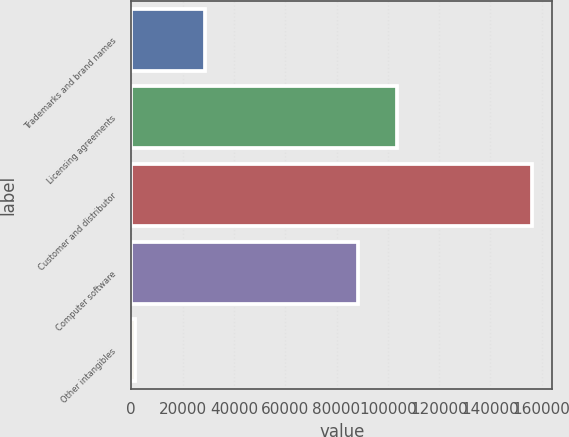Convert chart. <chart><loc_0><loc_0><loc_500><loc_500><bar_chart><fcel>Trademarks and brand names<fcel>Licensing agreements<fcel>Customer and distributor<fcel>Computer software<fcel>Other intangibles<nl><fcel>28617<fcel>103697<fcel>156340<fcel>88213<fcel>1498<nl></chart> 